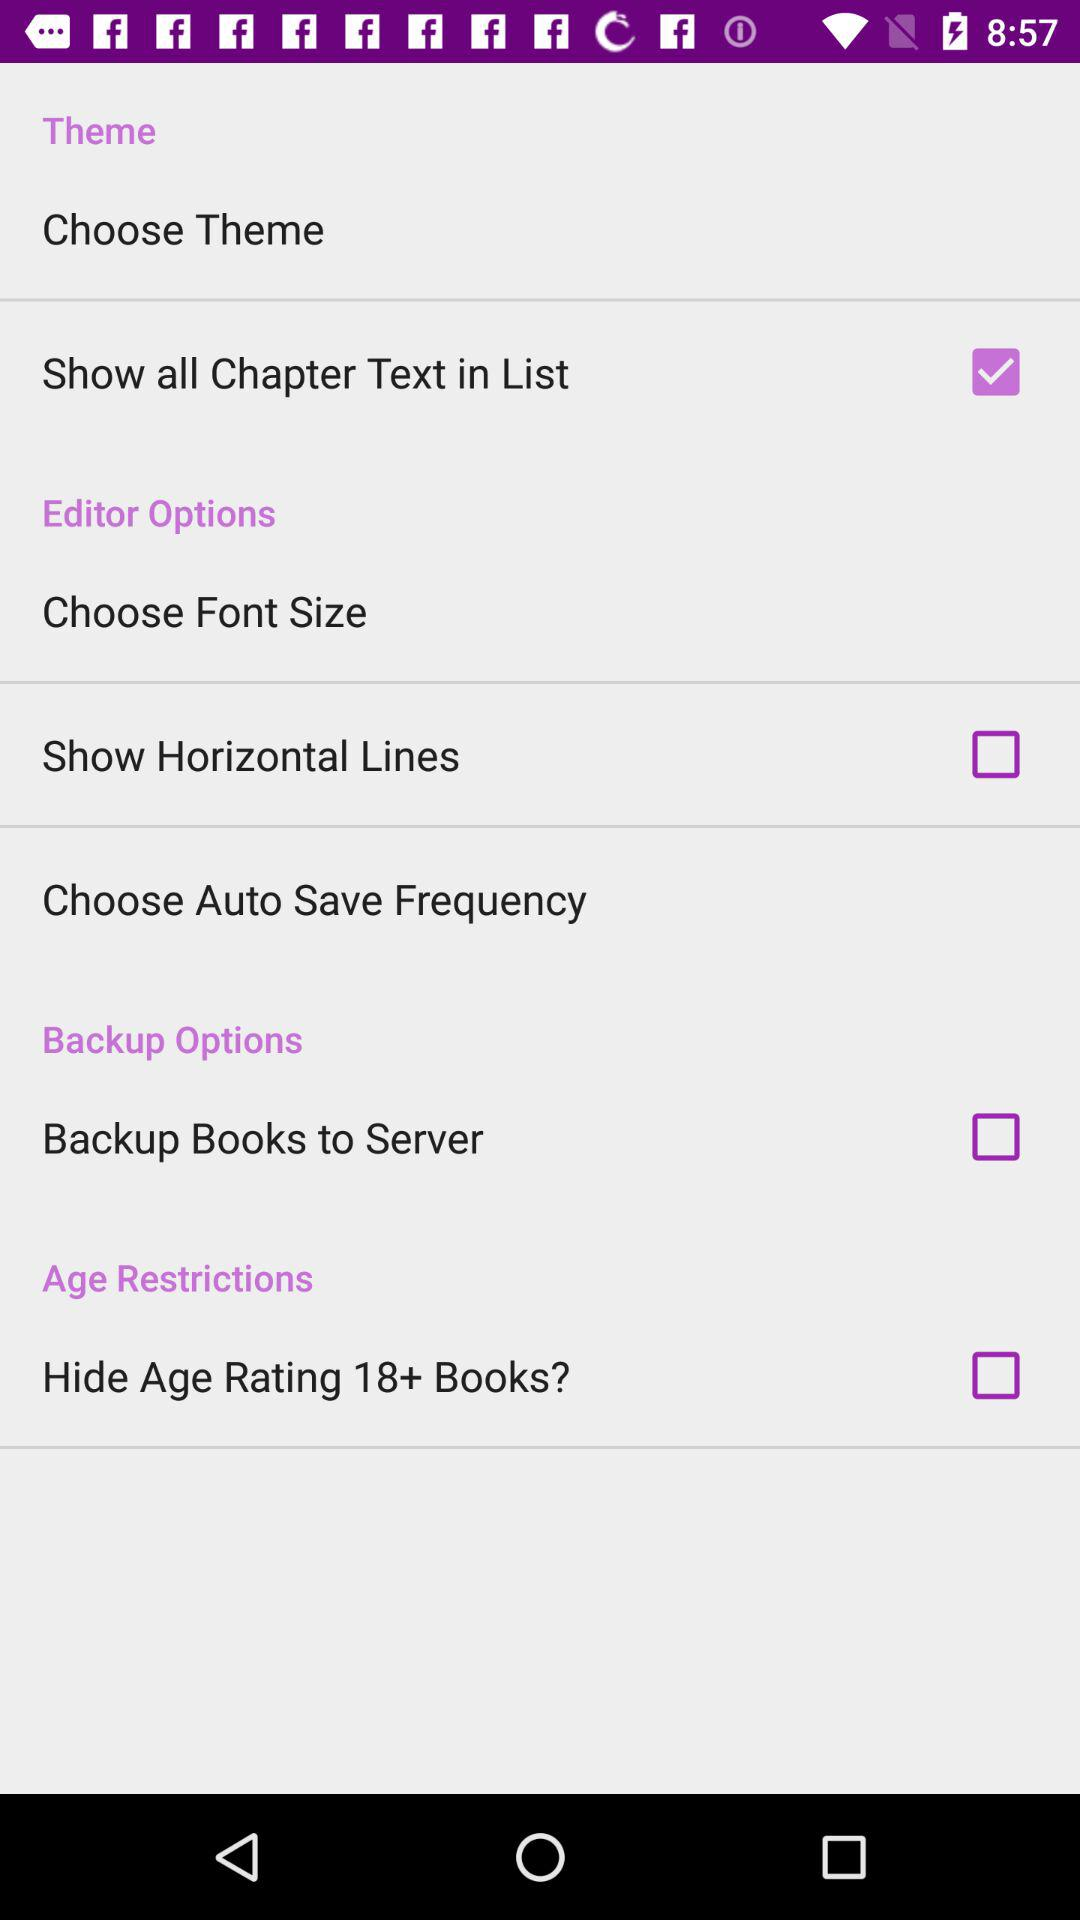What's the status of "Show all Chapter Text in List"? The status is "on". 